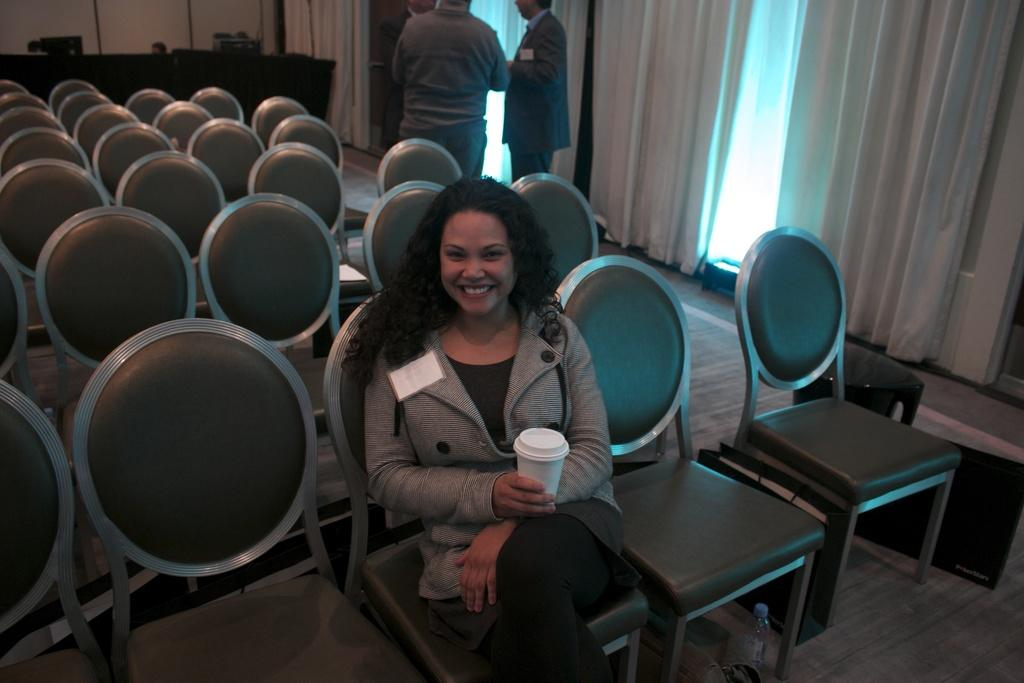What is the main subject of the image? The main subject of the image is a woman. What is the woman doing in the image? The woman is sitting on a chair and catching a glass with her hands. Are there any other people in the image? Yes, there are two persons behind the woman. What is the price of the glove in the image? There is no glove present in the image, so it is not possible to determine its price. 